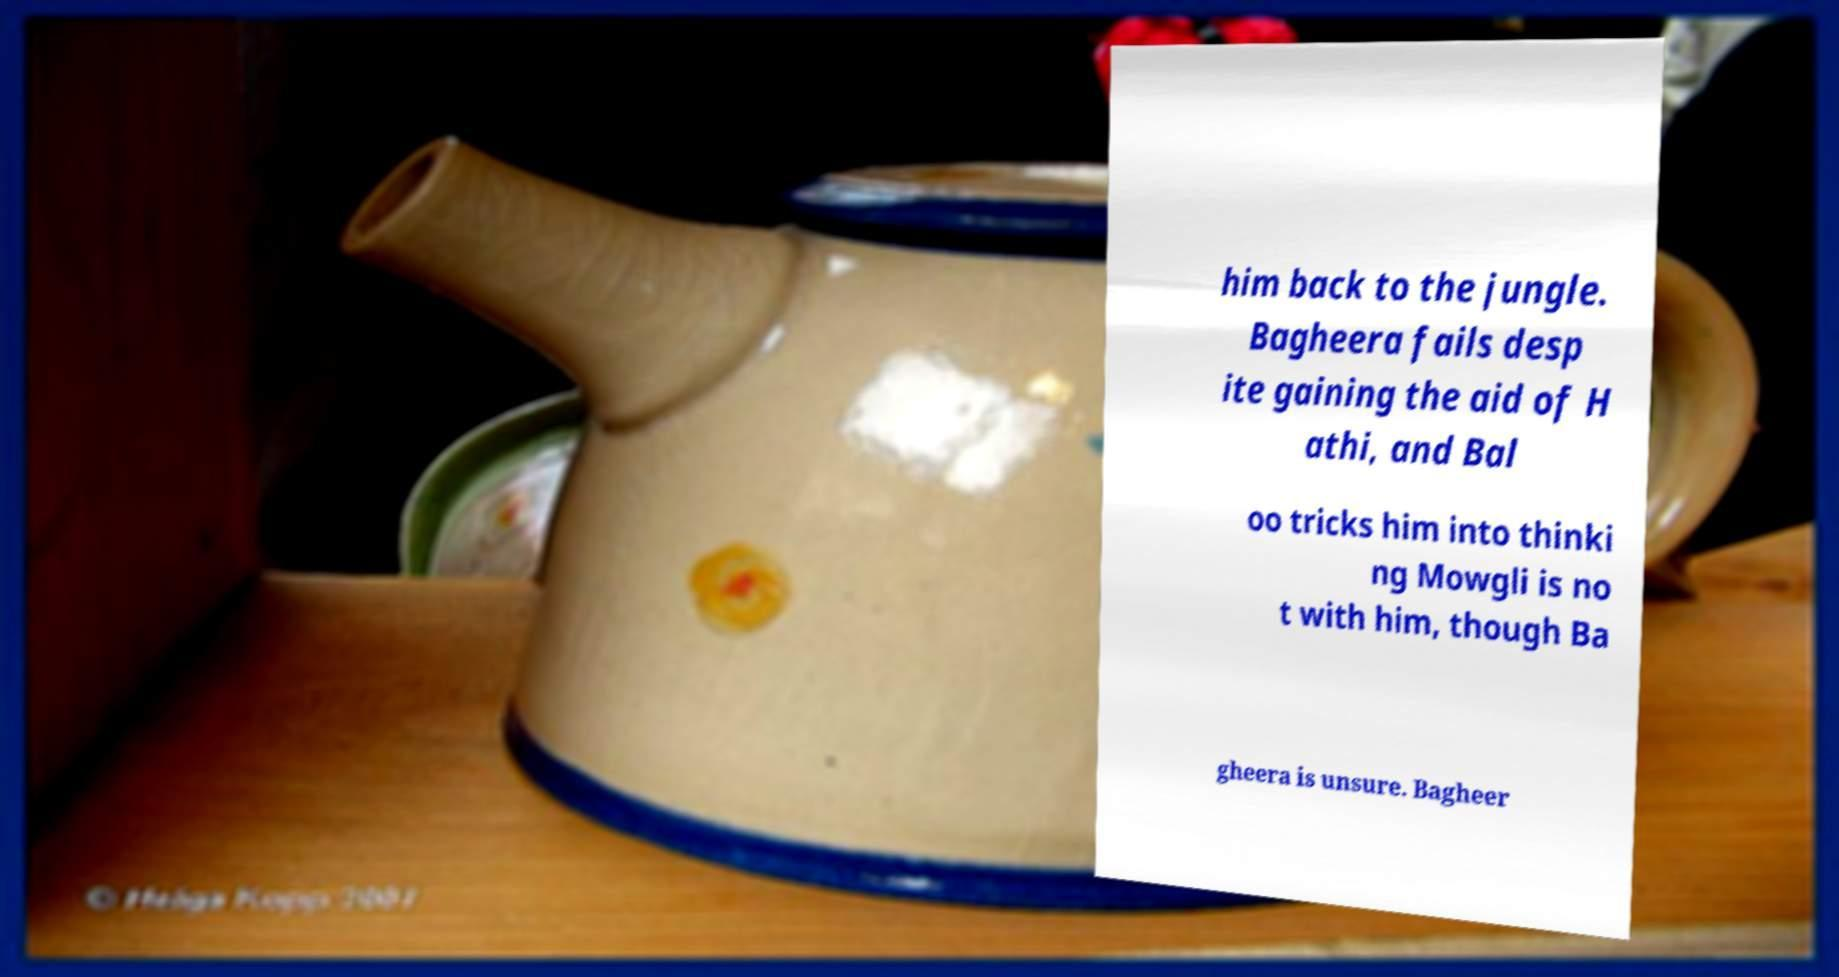Can you accurately transcribe the text from the provided image for me? him back to the jungle. Bagheera fails desp ite gaining the aid of H athi, and Bal oo tricks him into thinki ng Mowgli is no t with him, though Ba gheera is unsure. Bagheer 